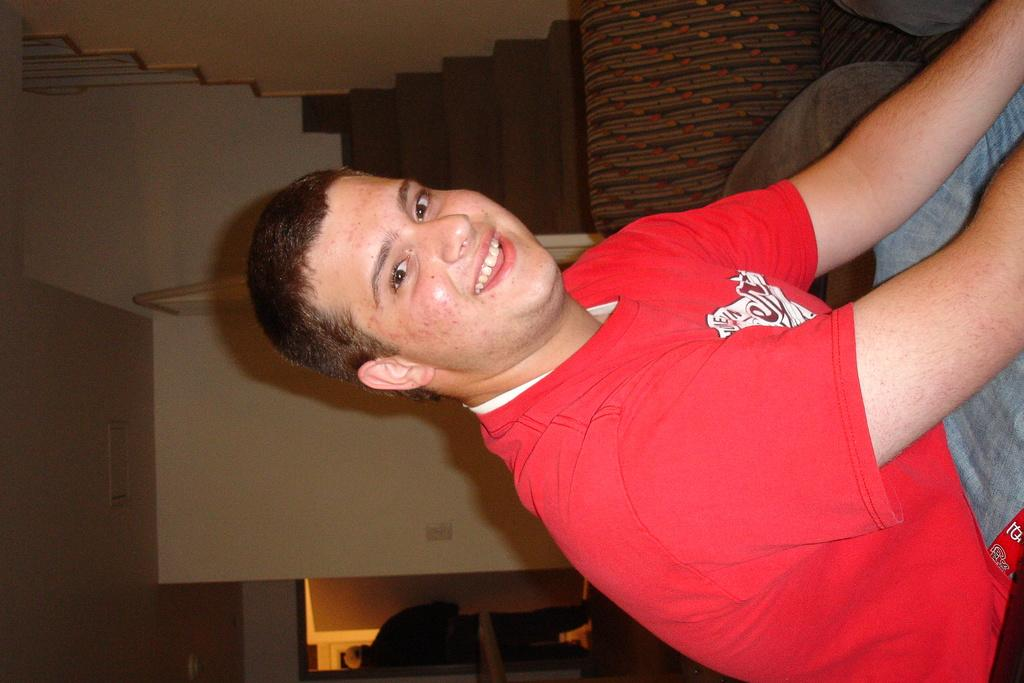What is the man in the image wearing? The man is wearing a red t-shirt. What is the man's facial expression in the image? The man is smiling. What is the man's posture in the image? The man is sitting. What can be seen in the background of the image? There is a couch, a staircase, a wall, and a person standing on the floor in the background of the image. What type of bird is perched on the man's shoulder in the image? There is no bird present in the image; the man is not accompanied by any bird. 